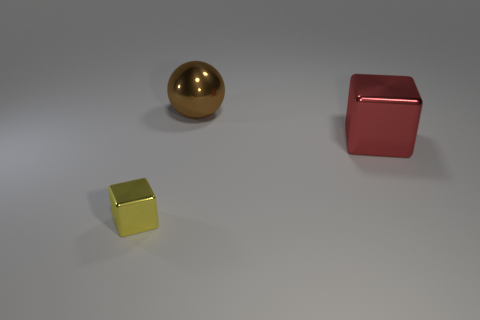Add 3 small gray metallic things. How many objects exist? 6 Subtract all blocks. How many objects are left? 1 Subtract 1 cubes. How many cubes are left? 1 Subtract all yellow things. Subtract all tiny rubber cylinders. How many objects are left? 2 Add 1 yellow shiny blocks. How many yellow shiny blocks are left? 2 Add 3 red cubes. How many red cubes exist? 4 Subtract 1 yellow blocks. How many objects are left? 2 Subtract all green cubes. Subtract all brown spheres. How many cubes are left? 2 